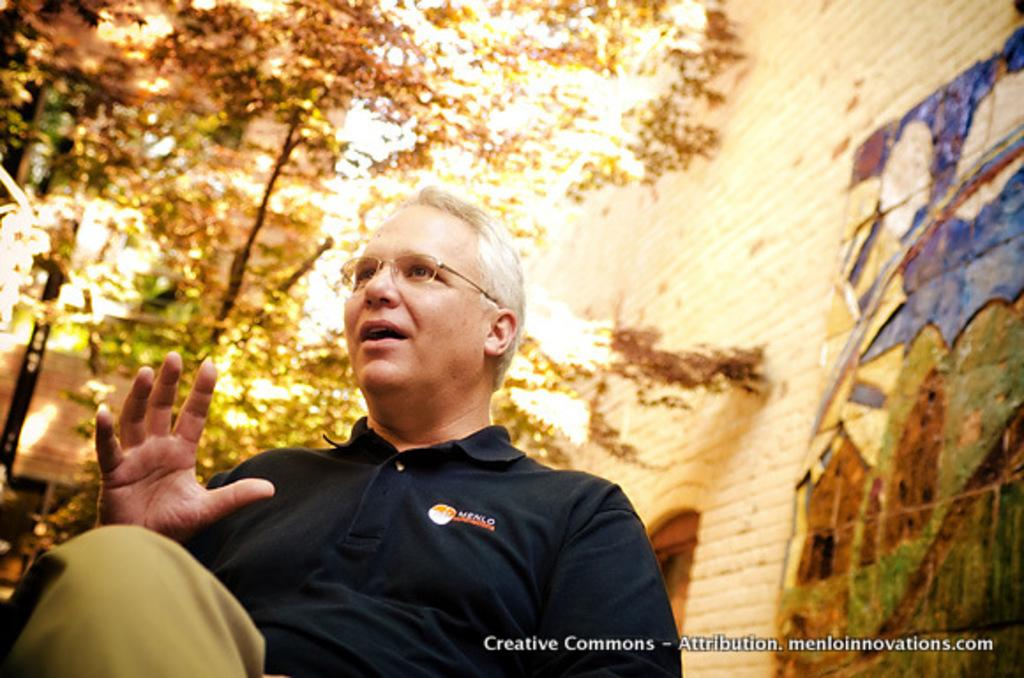What is the man in the image doing? The man is talking in the image. What can be found at the bottom of the image? There is text at the bottom of the image. What type of structure is visible on the right side of the image? There appears to be a building on the right side of the image. What type of vegetation is on the left side of the image? There are trees on the left side of the image. Can you see any salt being used in the image? There is no salt present in the image. What type of animals can be found in the cemetery in the image? There is no cemetery present in the image, so it is not possible to determine what animals might be found there. 